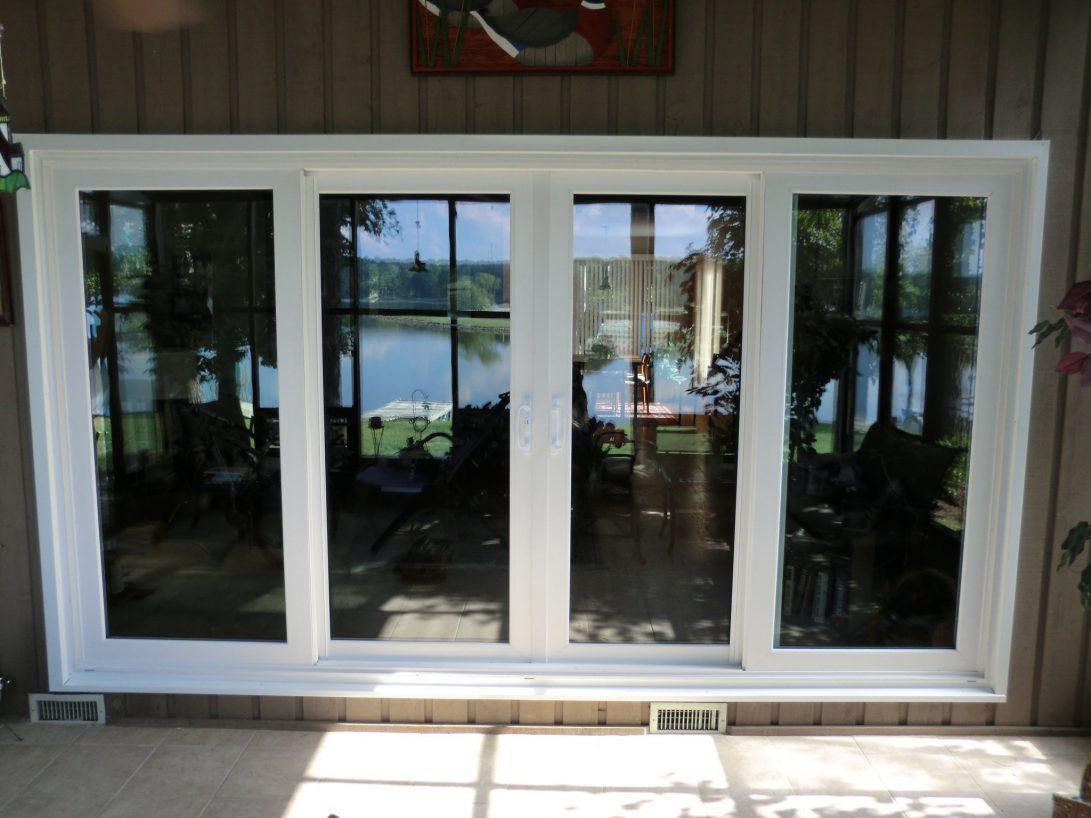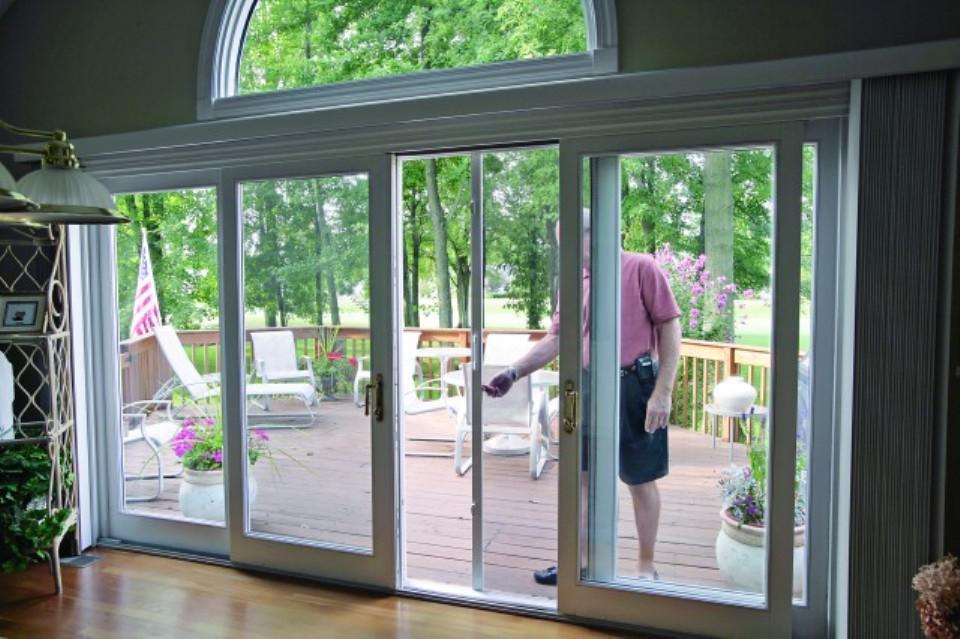The first image is the image on the left, the second image is the image on the right. For the images displayed, is the sentence "Two glass doors have white frames surrounding the panes." factually correct? Answer yes or no. Yes. The first image is the image on the left, the second image is the image on the right. Considering the images on both sides, is "In at least one image there are four closed tinted windows with white trim." valid? Answer yes or no. Yes. 